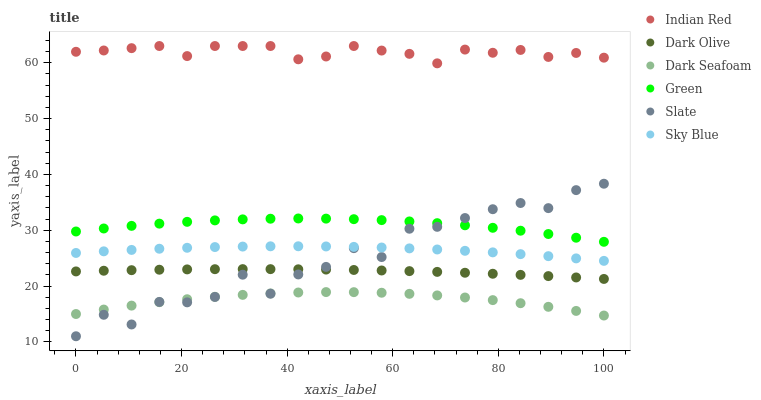Does Dark Seafoam have the minimum area under the curve?
Answer yes or no. Yes. Does Indian Red have the maximum area under the curve?
Answer yes or no. Yes. Does Dark Olive have the minimum area under the curve?
Answer yes or no. No. Does Dark Olive have the maximum area under the curve?
Answer yes or no. No. Is Dark Olive the smoothest?
Answer yes or no. Yes. Is Slate the roughest?
Answer yes or no. Yes. Is Dark Seafoam the smoothest?
Answer yes or no. No. Is Dark Seafoam the roughest?
Answer yes or no. No. Does Slate have the lowest value?
Answer yes or no. Yes. Does Dark Olive have the lowest value?
Answer yes or no. No. Does Indian Red have the highest value?
Answer yes or no. Yes. Does Dark Olive have the highest value?
Answer yes or no. No. Is Dark Seafoam less than Green?
Answer yes or no. Yes. Is Indian Red greater than Sky Blue?
Answer yes or no. Yes. Does Slate intersect Dark Olive?
Answer yes or no. Yes. Is Slate less than Dark Olive?
Answer yes or no. No. Is Slate greater than Dark Olive?
Answer yes or no. No. Does Dark Seafoam intersect Green?
Answer yes or no. No. 